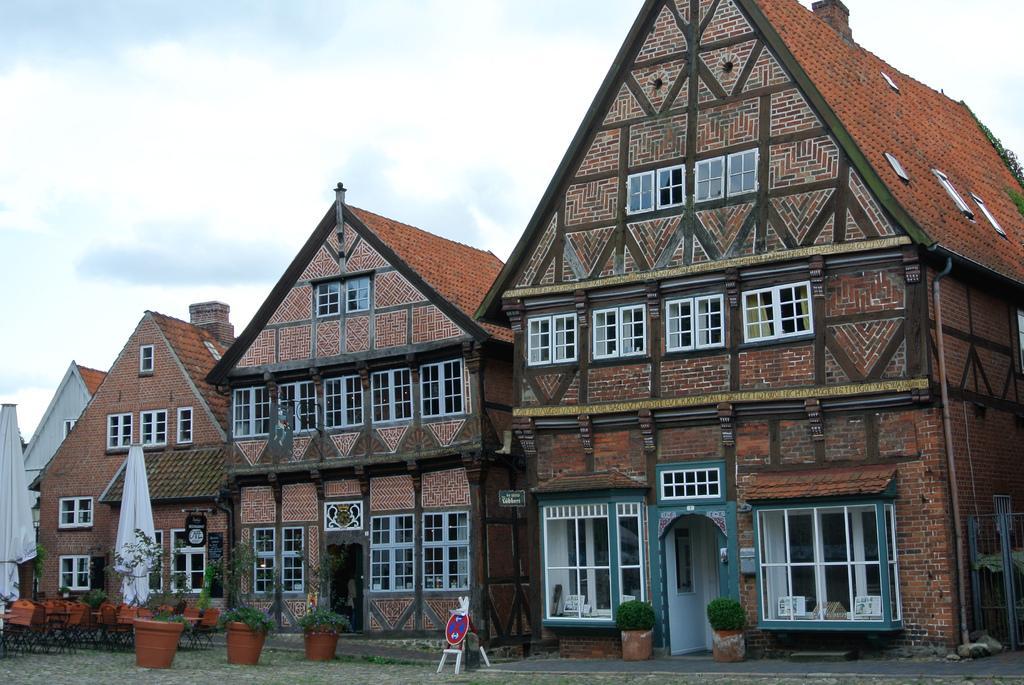Please provide a concise description of this image. In the picture we can see three buildings with windows and doors and near the buildings we can see some house plants and in the background we can see a sky with clouds. 